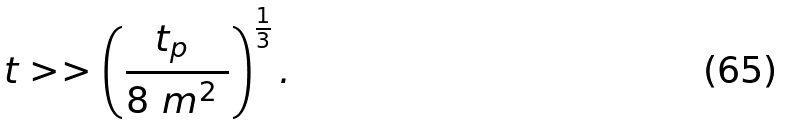Convert formula to latex. <formula><loc_0><loc_0><loc_500><loc_500>t > > \left ( \frac { t _ { p } \ } { 8 \ m ^ { 2 } \ } \right ) ^ { \frac { 1 } { 3 } } .</formula> 